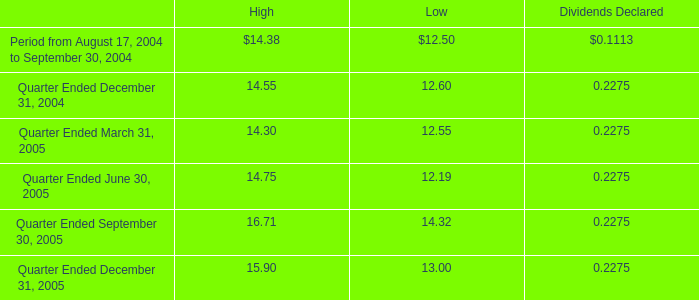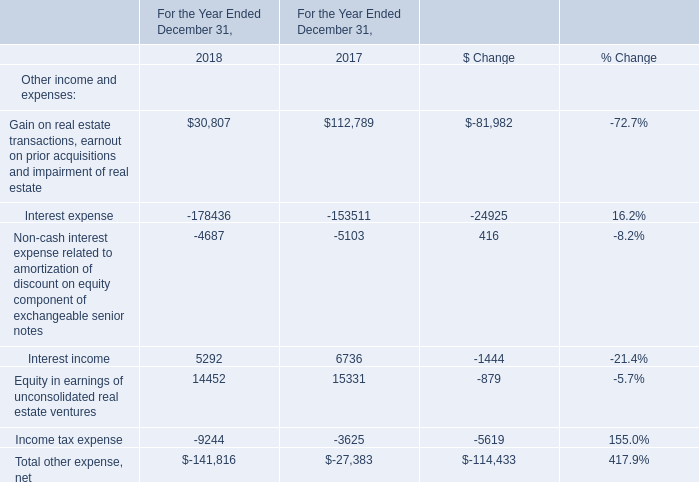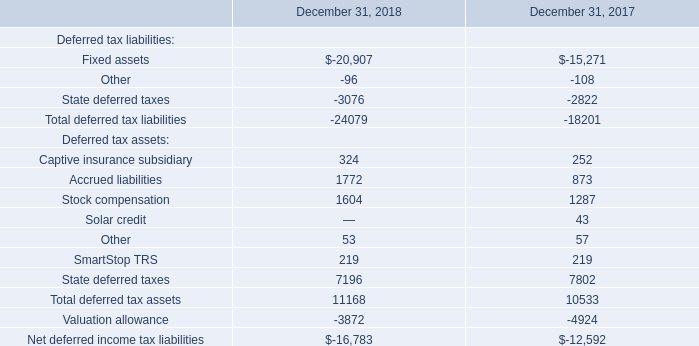What was the total amount of the Total other expense, net in the years where income tax expense is greater than 5000? 
Computations: (((((30807 - 178436) - 4687) + 5292) + 14452) - 9244)
Answer: -141816.0. 